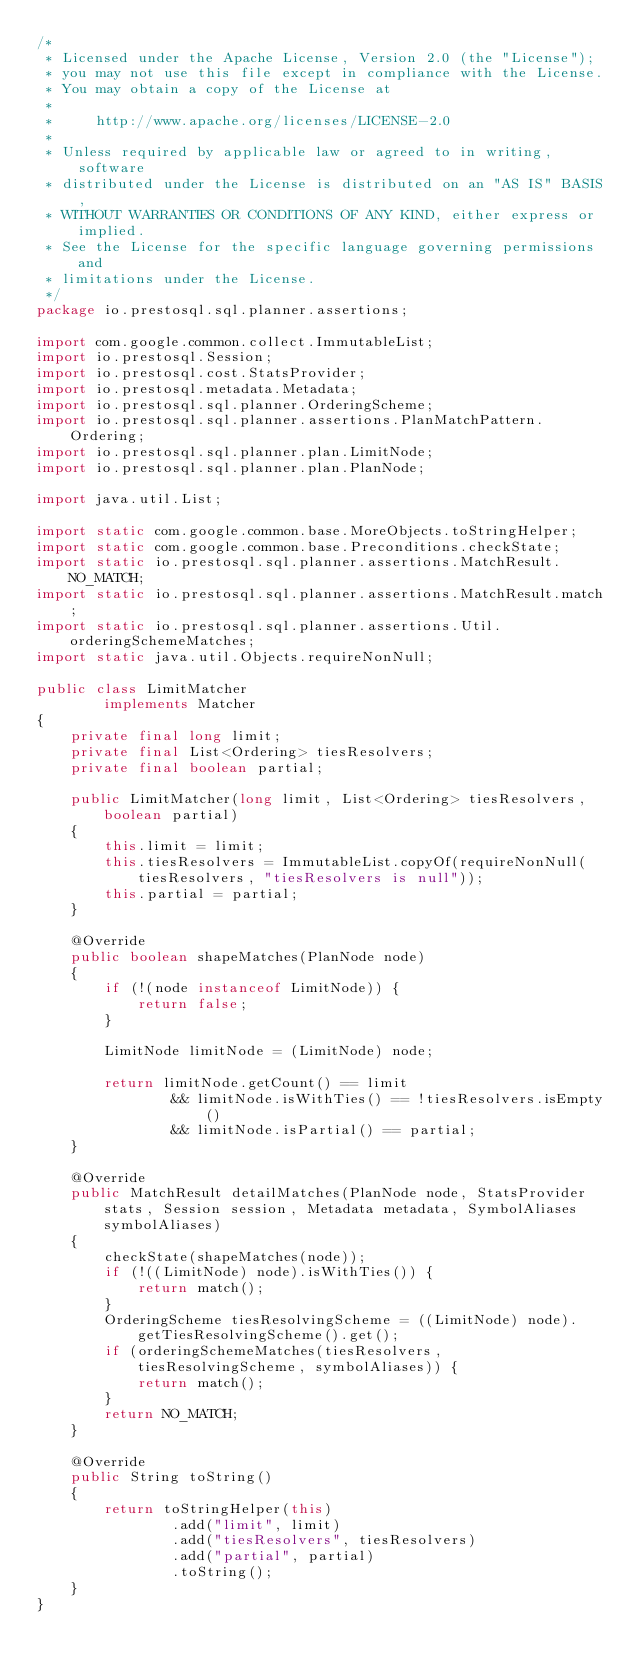Convert code to text. <code><loc_0><loc_0><loc_500><loc_500><_Java_>/*
 * Licensed under the Apache License, Version 2.0 (the "License");
 * you may not use this file except in compliance with the License.
 * You may obtain a copy of the License at
 *
 *     http://www.apache.org/licenses/LICENSE-2.0
 *
 * Unless required by applicable law or agreed to in writing, software
 * distributed under the License is distributed on an "AS IS" BASIS,
 * WITHOUT WARRANTIES OR CONDITIONS OF ANY KIND, either express or implied.
 * See the License for the specific language governing permissions and
 * limitations under the License.
 */
package io.prestosql.sql.planner.assertions;

import com.google.common.collect.ImmutableList;
import io.prestosql.Session;
import io.prestosql.cost.StatsProvider;
import io.prestosql.metadata.Metadata;
import io.prestosql.sql.planner.OrderingScheme;
import io.prestosql.sql.planner.assertions.PlanMatchPattern.Ordering;
import io.prestosql.sql.planner.plan.LimitNode;
import io.prestosql.sql.planner.plan.PlanNode;

import java.util.List;

import static com.google.common.base.MoreObjects.toStringHelper;
import static com.google.common.base.Preconditions.checkState;
import static io.prestosql.sql.planner.assertions.MatchResult.NO_MATCH;
import static io.prestosql.sql.planner.assertions.MatchResult.match;
import static io.prestosql.sql.planner.assertions.Util.orderingSchemeMatches;
import static java.util.Objects.requireNonNull;

public class LimitMatcher
        implements Matcher
{
    private final long limit;
    private final List<Ordering> tiesResolvers;
    private final boolean partial;

    public LimitMatcher(long limit, List<Ordering> tiesResolvers, boolean partial)
    {
        this.limit = limit;
        this.tiesResolvers = ImmutableList.copyOf(requireNonNull(tiesResolvers, "tiesResolvers is null"));
        this.partial = partial;
    }

    @Override
    public boolean shapeMatches(PlanNode node)
    {
        if (!(node instanceof LimitNode)) {
            return false;
        }

        LimitNode limitNode = (LimitNode) node;

        return limitNode.getCount() == limit
                && limitNode.isWithTies() == !tiesResolvers.isEmpty()
                && limitNode.isPartial() == partial;
    }

    @Override
    public MatchResult detailMatches(PlanNode node, StatsProvider stats, Session session, Metadata metadata, SymbolAliases symbolAliases)
    {
        checkState(shapeMatches(node));
        if (!((LimitNode) node).isWithTies()) {
            return match();
        }
        OrderingScheme tiesResolvingScheme = ((LimitNode) node).getTiesResolvingScheme().get();
        if (orderingSchemeMatches(tiesResolvers, tiesResolvingScheme, symbolAliases)) {
            return match();
        }
        return NO_MATCH;
    }

    @Override
    public String toString()
    {
        return toStringHelper(this)
                .add("limit", limit)
                .add("tiesResolvers", tiesResolvers)
                .add("partial", partial)
                .toString();
    }
}
</code> 